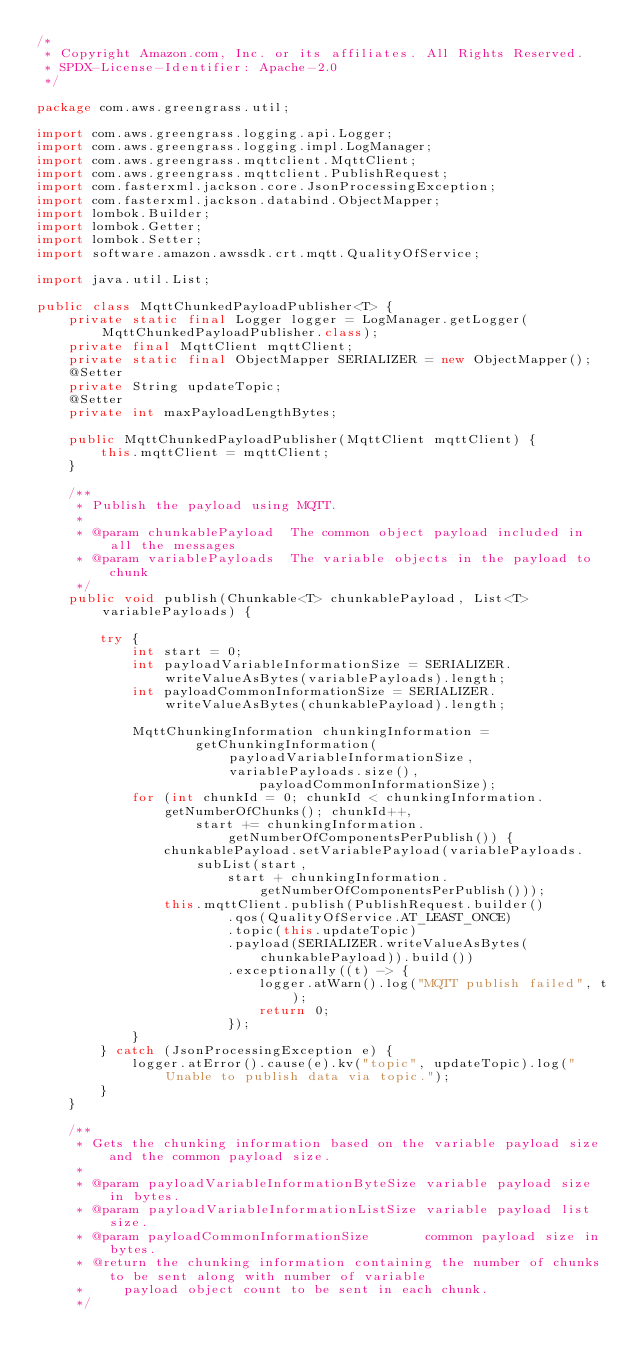<code> <loc_0><loc_0><loc_500><loc_500><_Java_>/*
 * Copyright Amazon.com, Inc. or its affiliates. All Rights Reserved.
 * SPDX-License-Identifier: Apache-2.0
 */

package com.aws.greengrass.util;

import com.aws.greengrass.logging.api.Logger;
import com.aws.greengrass.logging.impl.LogManager;
import com.aws.greengrass.mqttclient.MqttClient;
import com.aws.greengrass.mqttclient.PublishRequest;
import com.fasterxml.jackson.core.JsonProcessingException;
import com.fasterxml.jackson.databind.ObjectMapper;
import lombok.Builder;
import lombok.Getter;
import lombok.Setter;
import software.amazon.awssdk.crt.mqtt.QualityOfService;

import java.util.List;

public class MqttChunkedPayloadPublisher<T> {
    private static final Logger logger = LogManager.getLogger(MqttChunkedPayloadPublisher.class);
    private final MqttClient mqttClient;
    private static final ObjectMapper SERIALIZER = new ObjectMapper();
    @Setter
    private String updateTopic;
    @Setter
    private int maxPayloadLengthBytes;

    public MqttChunkedPayloadPublisher(MqttClient mqttClient) {
        this.mqttClient = mqttClient;
    }

    /**
     * Publish the payload using MQTT.
     *
     * @param chunkablePayload  The common object payload included in all the messages
     * @param variablePayloads  The variable objects in the payload to chunk
     */
    public void publish(Chunkable<T> chunkablePayload, List<T> variablePayloads) {

        try {
            int start = 0;
            int payloadVariableInformationSize = SERIALIZER.writeValueAsBytes(variablePayloads).length;
            int payloadCommonInformationSize = SERIALIZER.writeValueAsBytes(chunkablePayload).length;

            MqttChunkingInformation chunkingInformation =
                    getChunkingInformation(payloadVariableInformationSize, variablePayloads.size(),
                            payloadCommonInformationSize);
            for (int chunkId = 0; chunkId < chunkingInformation.getNumberOfChunks(); chunkId++,
                    start += chunkingInformation.getNumberOfComponentsPerPublish()) {
                chunkablePayload.setVariablePayload(variablePayloads.subList(start,
                        start + chunkingInformation.getNumberOfComponentsPerPublish()));
                this.mqttClient.publish(PublishRequest.builder()
                        .qos(QualityOfService.AT_LEAST_ONCE)
                        .topic(this.updateTopic)
                        .payload(SERIALIZER.writeValueAsBytes(chunkablePayload)).build())
                        .exceptionally((t) -> {
                            logger.atWarn().log("MQTT publish failed", t);
                            return 0;
                        });
            }
        } catch (JsonProcessingException e) {
            logger.atError().cause(e).kv("topic", updateTopic).log("Unable to publish data via topic.");
        }
    }

    /**
     * Gets the chunking information based on the variable payload size and the common payload size.
     *
     * @param payloadVariableInformationByteSize variable payload size in bytes.
     * @param payloadVariableInformationListSize variable payload list size.
     * @param payloadCommonInformationSize       common payload size in bytes.
     * @return the chunking information containing the number of chunks to be sent along with number of variable
     *     payload object count to be sent in each chunk.
     */</code> 